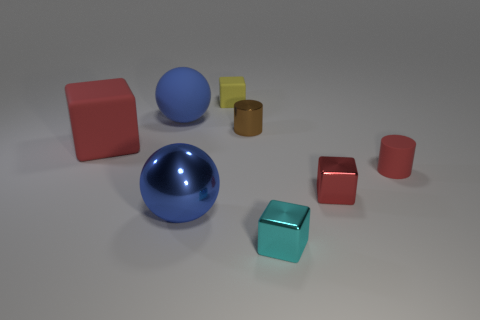What number of matte things are either large objects or brown cylinders?
Make the answer very short. 2. Is there a purple object that has the same material as the red cylinder?
Offer a terse response. No. How many things are tiny cylinders to the right of the small brown metal cylinder or objects that are left of the metal sphere?
Ensure brevity in your answer.  3. There is a large rubber object behind the red rubber block; is it the same color as the big metal sphere?
Make the answer very short. Yes. How many other objects are the same color as the large rubber ball?
Make the answer very short. 1. What is the material of the yellow thing?
Your answer should be very brief. Rubber. There is a red object on the left side of the yellow block; is its size the same as the cyan object?
Make the answer very short. No. Is there anything else that has the same size as the red shiny thing?
Provide a short and direct response. Yes. What size is the yellow thing that is the same shape as the cyan metallic object?
Provide a short and direct response. Small. Is the number of blue matte balls right of the metal ball the same as the number of red rubber things that are on the right side of the big red thing?
Ensure brevity in your answer.  No. 